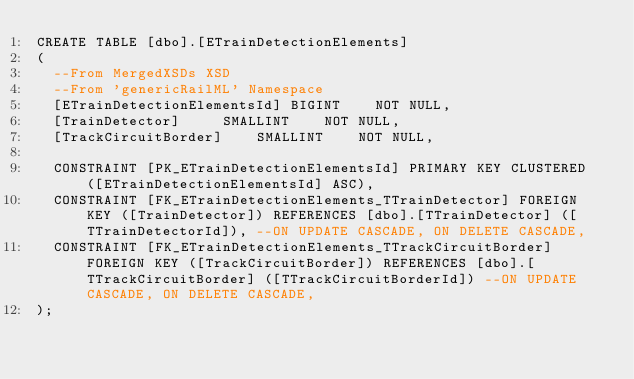<code> <loc_0><loc_0><loc_500><loc_500><_SQL_>CREATE TABLE [dbo].[ETrainDetectionElements]
(
	--From MergedXSDs XSD
	--From 'genericRailML' Namespace
	[ETrainDetectionElementsId]	BIGINT		NOT NULL,
	[TrainDetector]			SMALLINT		NOT NULL,
	[TrackCircuitBorder]		SMALLINT		NOT NULL,

	CONSTRAINT [PK_ETrainDetectionElementsId] PRIMARY KEY CLUSTERED ([ETrainDetectionElementsId] ASC),
	CONSTRAINT [FK_ETrainDetectionElements_TTrainDetector] FOREIGN KEY ([TrainDetector]) REFERENCES [dbo].[TTrainDetector] ([TTrainDetectorId]), --ON UPDATE CASCADE, ON DELETE CASCADE,
	CONSTRAINT [FK_ETrainDetectionElements_TTrackCircuitBorder] FOREIGN KEY ([TrackCircuitBorder]) REFERENCES [dbo].[TTrackCircuitBorder] ([TTrackCircuitBorderId]) --ON UPDATE CASCADE, ON DELETE CASCADE,
);
</code> 